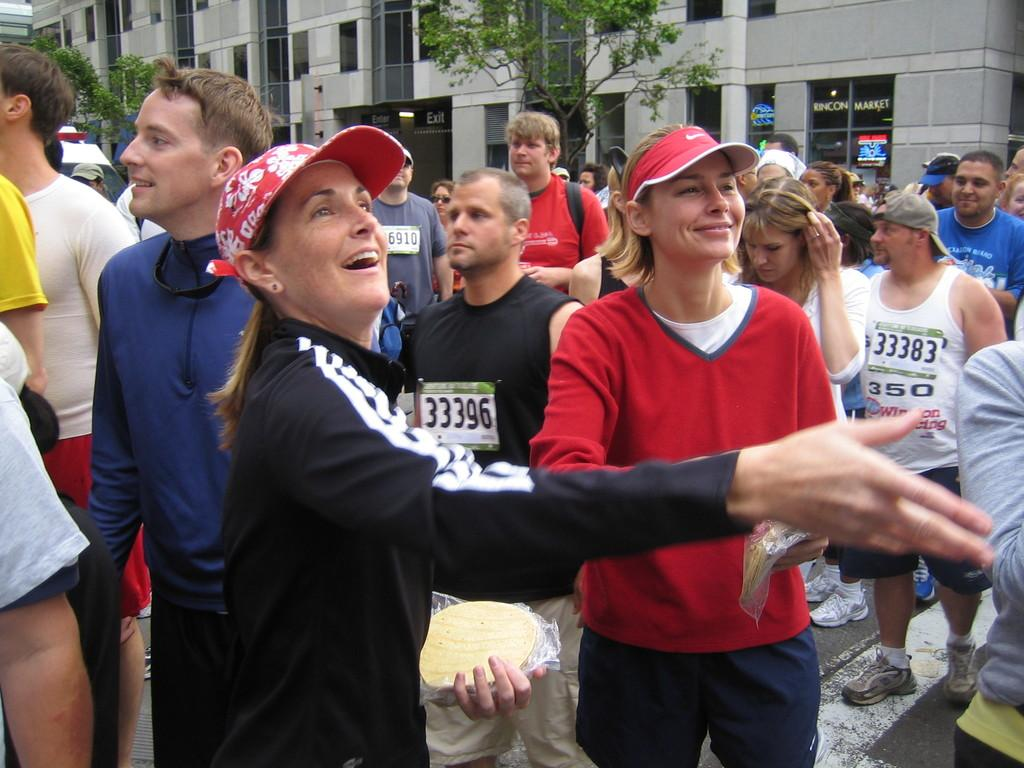What is happening on the road in the image? There are many people standing on the road in the image, and it appears to be a marathon. What can be seen in the background of the image? There are buildings visible in the background of the image, and trees are present in front of the buildings. What type of business is being attacked in the image? There is no business or attack depicted in the image; it shows a marathon taking place on the road. What type of canvas is being used to paint the scene in the image? The image is a photograph and not a painting, so there is no canvas present. 